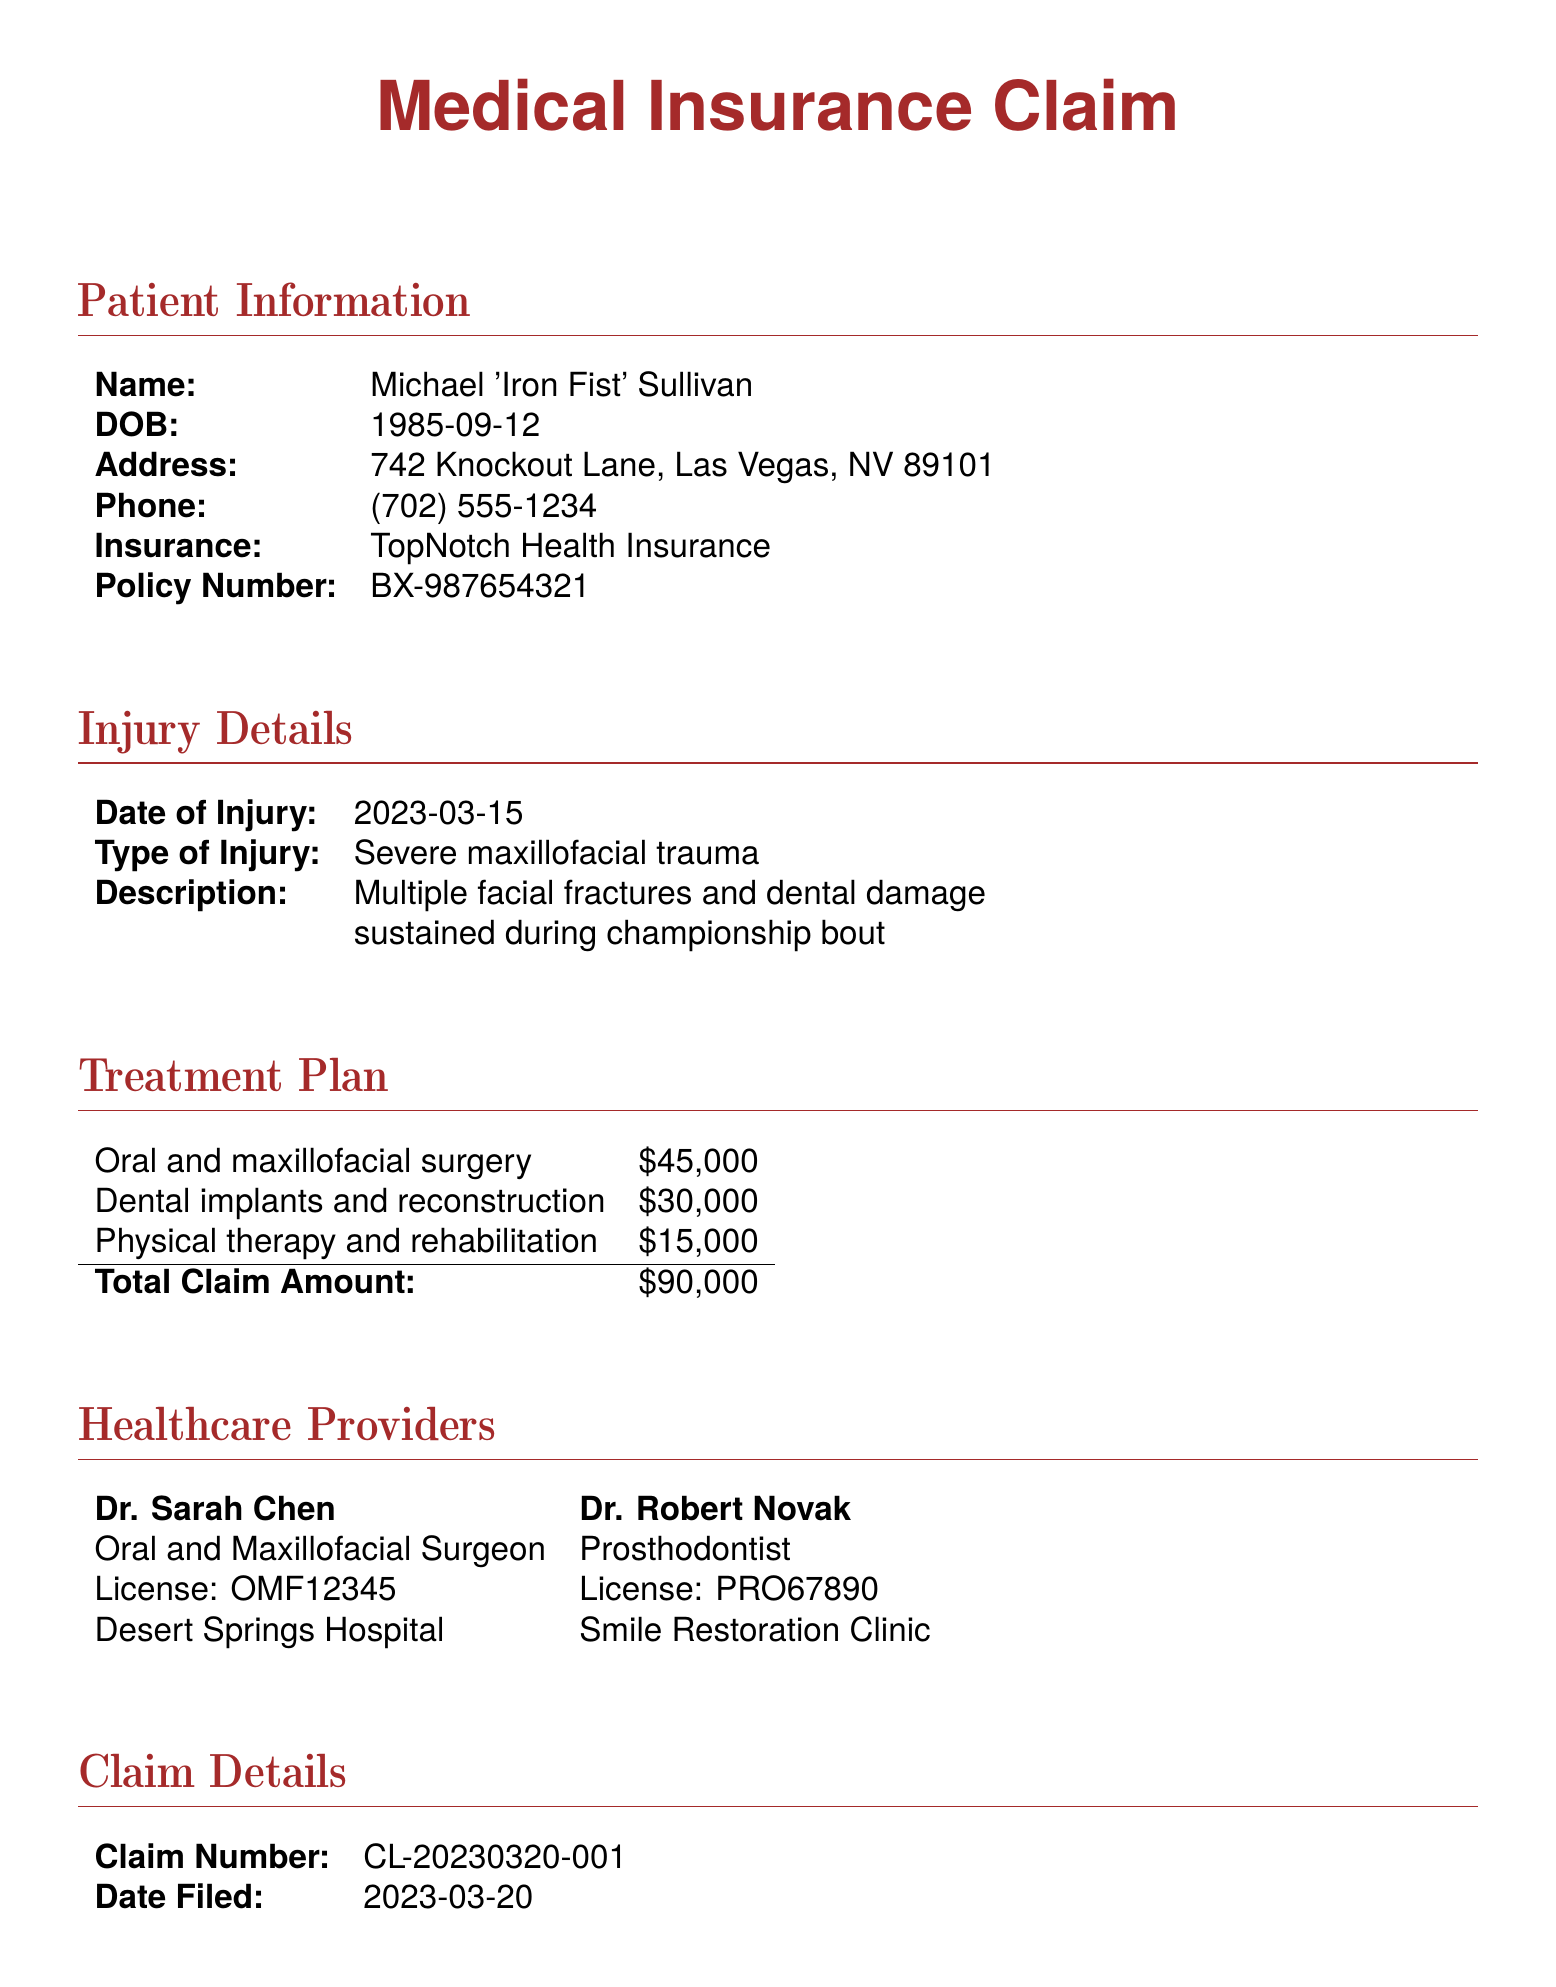what is the total claim amount? The total claim amount is the sum of all treatment costs listed in the document, which is $45,000 + $30,000 + $15,000 = $90,000.
Answer: $90,000 who is the oral and maxillofacial surgeon? Dr. Sarah Chen is identified in the document as the oral and maxillofacial surgeon.
Answer: Dr. Sarah Chen what is the date of injury? The date of injury is specifically stated in the document.
Answer: 2023-03-15 how much does physical therapy and rehabilitation cost? The cost for physical therapy and rehabilitation is clearly listed in the treatment plan section.
Answer: $15,000 what is Michael Sullivan's insurance policy number? The insurance policy number can be found under the patient information section of the document.
Answer: BX-987654321 which boxing association is mentioned? The boxing association is specified under the additional information section of the document.
Answer: World Boxing Association (WBA) when was the claim filed? The claim filing date is provided in the claim details section.
Answer: 2023-03-20 what type of injury did Michael Sullivan have? The type of injury is clearly described in the injury details section of the document.
Answer: Severe maxillofacial trauma 